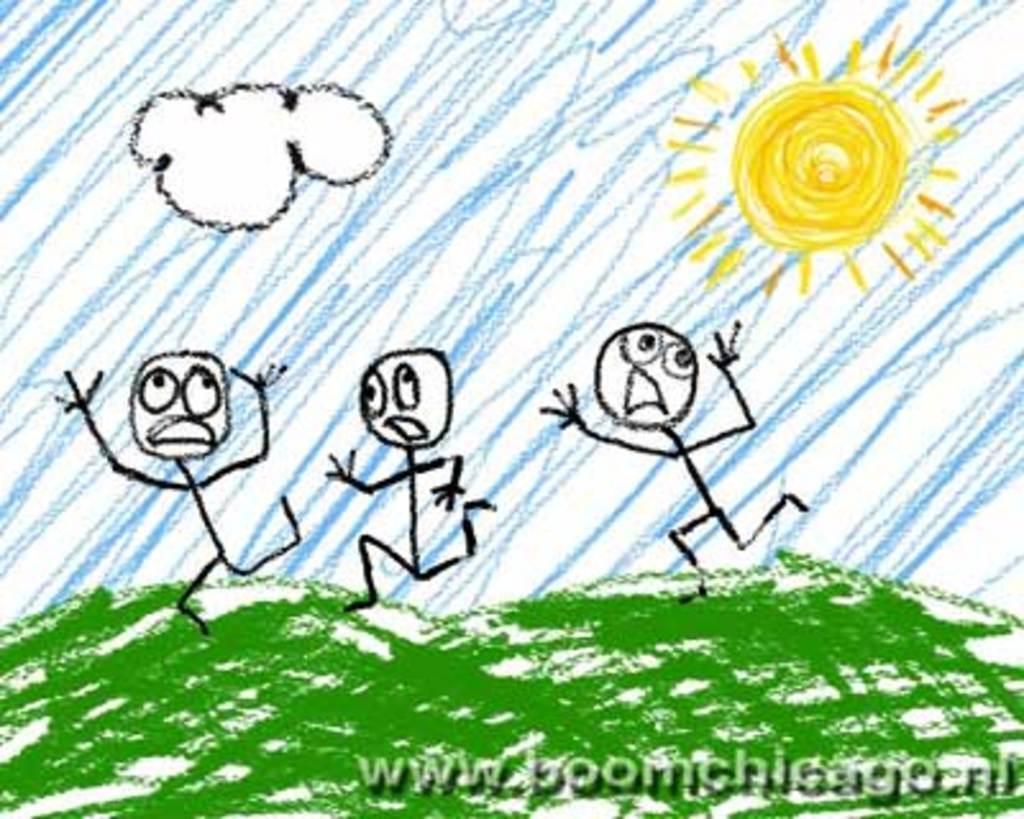Could you give a brief overview of what you see in this image? In this image I can see a drawing of the three people,sun and a cloud. They are in green,white,blue and yellow color. 